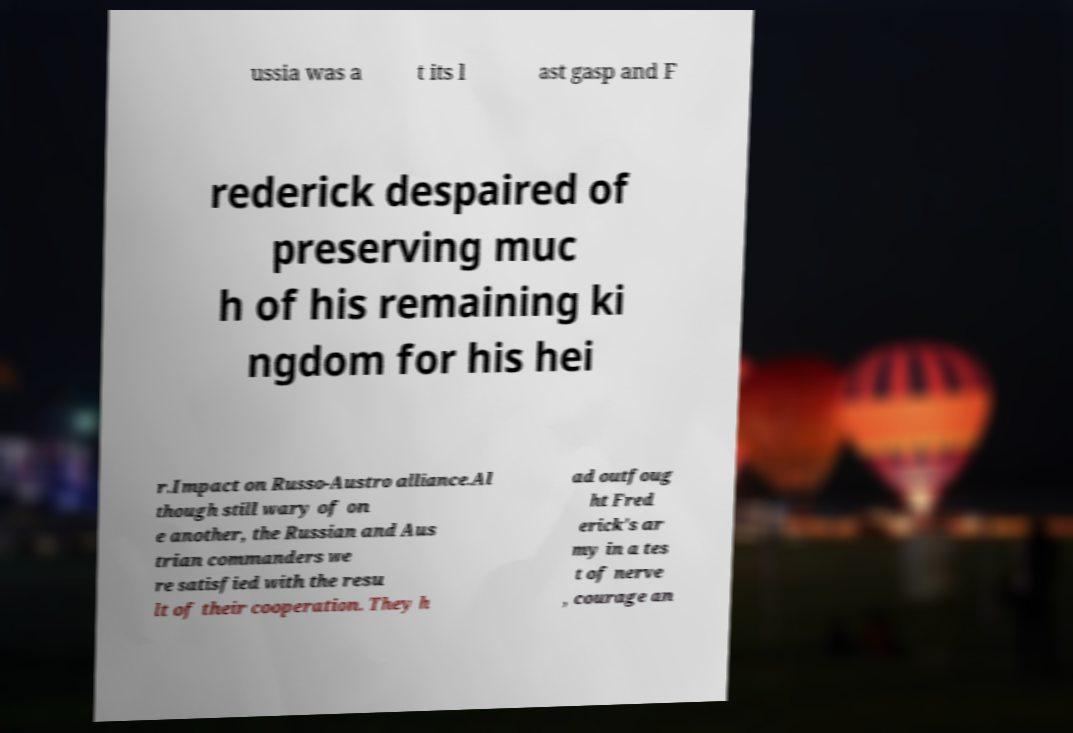Could you assist in decoding the text presented in this image and type it out clearly? ussia was a t its l ast gasp and F rederick despaired of preserving muc h of his remaining ki ngdom for his hei r.Impact on Russo-Austro alliance.Al though still wary of on e another, the Russian and Aus trian commanders we re satisfied with the resu lt of their cooperation. They h ad outfoug ht Fred erick's ar my in a tes t of nerve , courage an 